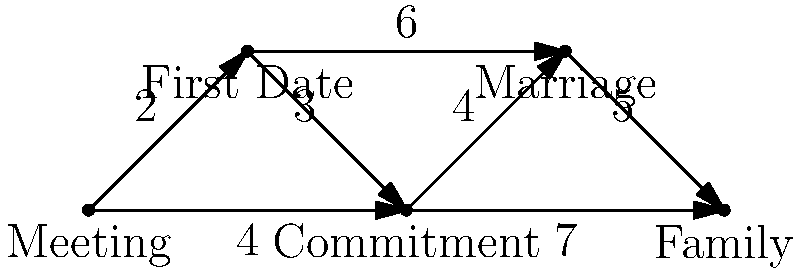In a relationship journey, each milestone is represented by a node, and the paths between them represent shared experiences. The weight of each path indicates the time and effort invested. What is the shortest path from "Meeting" to "Family" in terms of total weight, and what does this path represent in the context of building trust in a marriage? To find the shortest path, we need to consider all possible routes from "Meeting" to "Family" and calculate their total weights:

1. Meeting → First Date → Commitment → Marriage → Family
   Total weight: 2 + 3 + 4 + 5 = 14

2. Meeting → First Date → Marriage → Family
   Total weight: 2 + 6 + 5 = 13

3. Meeting → Commitment → Marriage → Family
   Total weight: 4 + 4 + 5 = 13

4. Meeting → Commitment → Family
   Total weight: 4 + 7 = 11

The shortest path is Meeting → Commitment → Family, with a total weight of 11.

In the context of building trust in a marriage, this path represents:

1. Meeting: The initial encounter where trust begins to form.
2. Commitment: A significant step in the relationship where both partners decide to invest in a long-term future together. This stage involves open communication, shared values, and mutual understanding.
3. Family: The culmination of trust-building efforts, where the couple commits to creating and nurturing a family unit together.

This path suggests that while traditional milestones like "First Date" and "Marriage" are important, the key to building trust in a marriage lies in the quality of commitment and the shared vision of family life. It emphasizes that trust is built through consistent actions and shared goals rather than simply following societal expectations or timelines.
Answer: Meeting → Commitment → Family (weight: 11) 